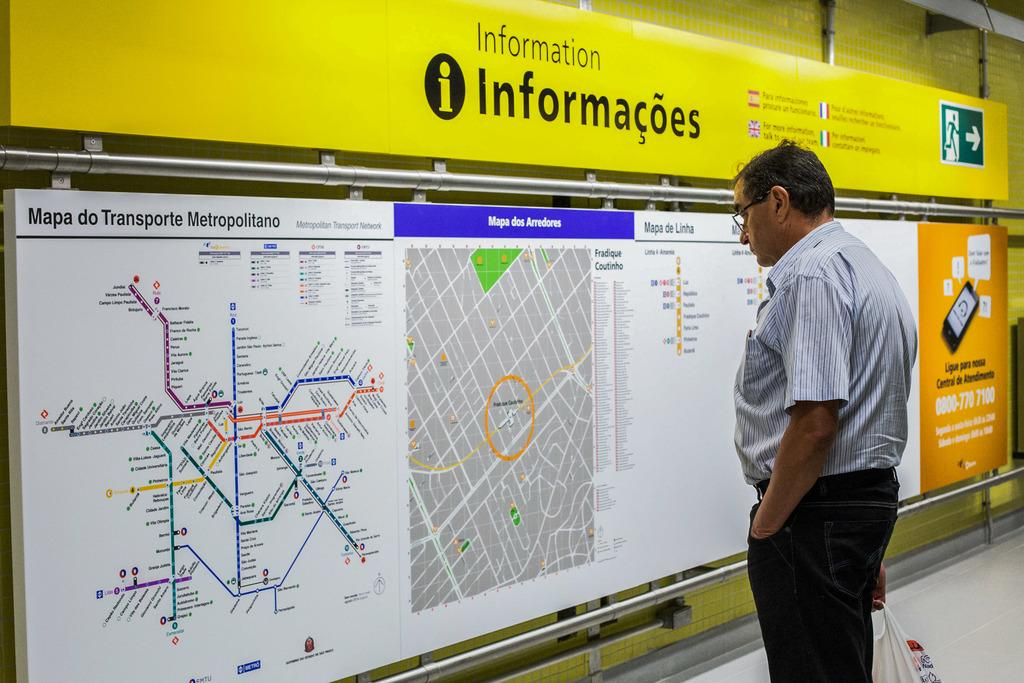What is the person in the image holding? The person is holding a cover bag in the image. What can be seen beneath the person's feet in the image? The ground is visible in the image. What type of signage is present in the image? There are boards with text and images in the image. What type of structure is present in the background of the image? There is a wall in the image. What type of vertical structures are present in the image? There are poles in the image. What type of channel can be seen in the image? There is no channel present in the image. What type of pipe is visible in the image? There is no pipe visible in the image. 